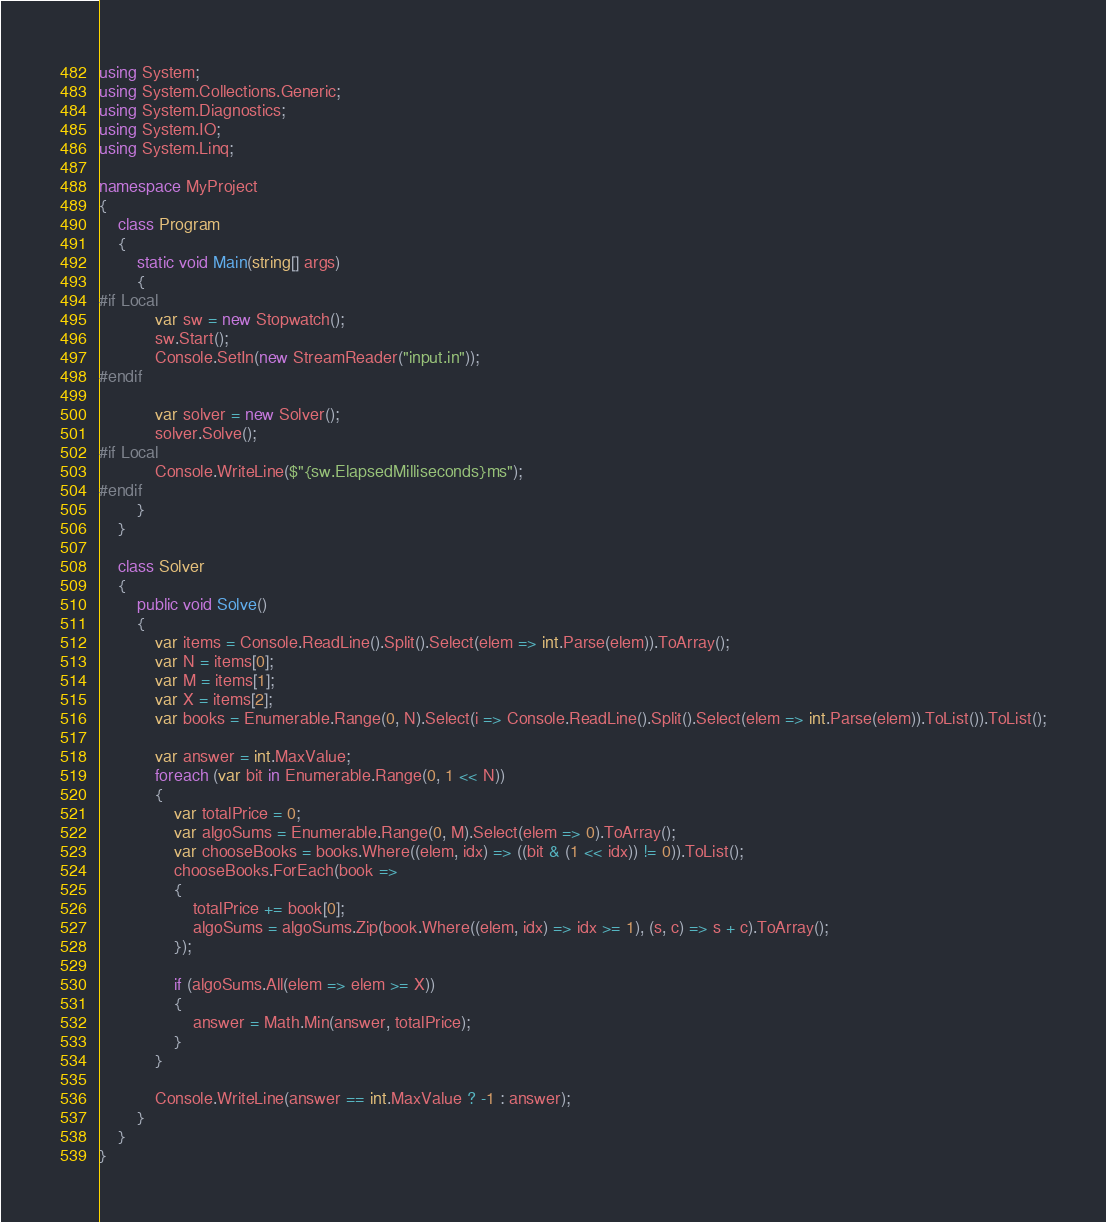<code> <loc_0><loc_0><loc_500><loc_500><_C#_>using System;
using System.Collections.Generic;
using System.Diagnostics;
using System.IO;
using System.Linq;

namespace MyProject
{
    class Program
    {
        static void Main(string[] args)
        {
#if Local
            var sw = new Stopwatch();
            sw.Start();
            Console.SetIn(new StreamReader("input.in"));
#endif

            var solver = new Solver();
            solver.Solve();
#if Local
            Console.WriteLine($"{sw.ElapsedMilliseconds}ms");
#endif
        }
    }

    class Solver
    {
        public void Solve()
        {
            var items = Console.ReadLine().Split().Select(elem => int.Parse(elem)).ToArray();
            var N = items[0];
            var M = items[1];
            var X = items[2];
            var books = Enumerable.Range(0, N).Select(i => Console.ReadLine().Split().Select(elem => int.Parse(elem)).ToList()).ToList();

            var answer = int.MaxValue;
            foreach (var bit in Enumerable.Range(0, 1 << N))
            {
                var totalPrice = 0;
                var algoSums = Enumerable.Range(0, M).Select(elem => 0).ToArray();
                var chooseBooks = books.Where((elem, idx) => ((bit & (1 << idx)) != 0)).ToList();
                chooseBooks.ForEach(book =>
                {
                    totalPrice += book[0];
                    algoSums = algoSums.Zip(book.Where((elem, idx) => idx >= 1), (s, c) => s + c).ToArray();
                });

                if (algoSums.All(elem => elem >= X))
                {
                    answer = Math.Min(answer, totalPrice);
                }
            }

            Console.WriteLine(answer == int.MaxValue ? -1 : answer);
        }
    }
}
</code> 